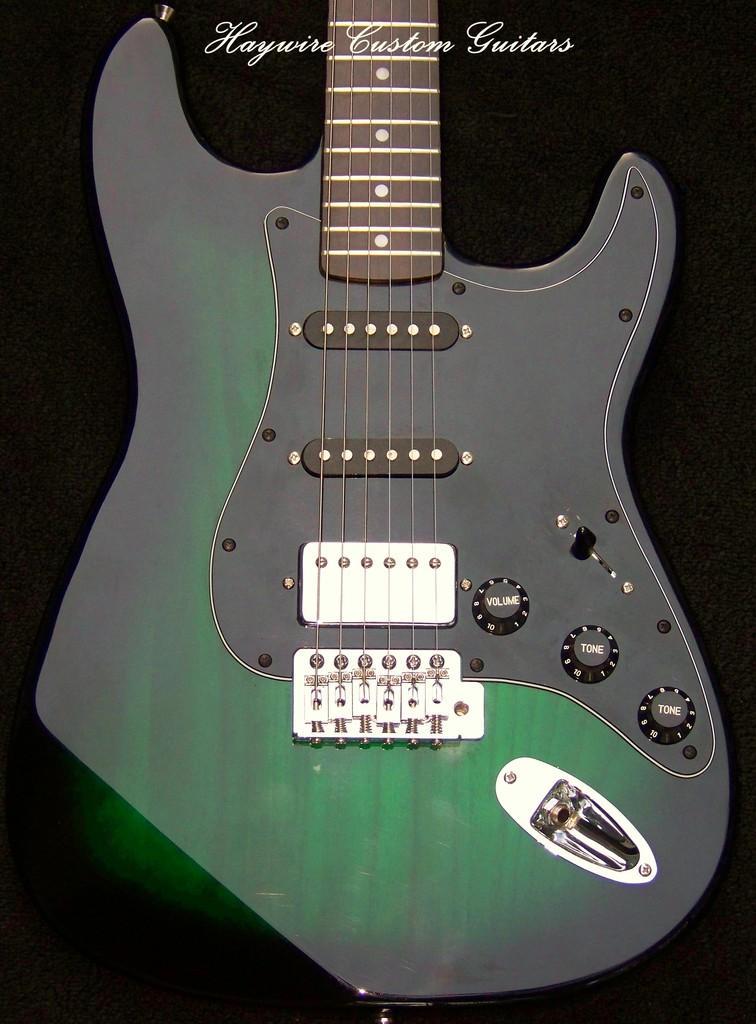Please provide a concise description of this image. In the image there is a green color guitar. 